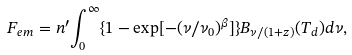Convert formula to latex. <formula><loc_0><loc_0><loc_500><loc_500>F _ { e m } = n ^ { \prime } { \int _ { 0 } ^ { \infty } \{ 1 - \exp [ - ( \nu / \nu _ { 0 } ) ^ { \beta } ] \} B _ { \nu / ( 1 + z ) } ( T _ { d } ) d \nu } ,</formula> 